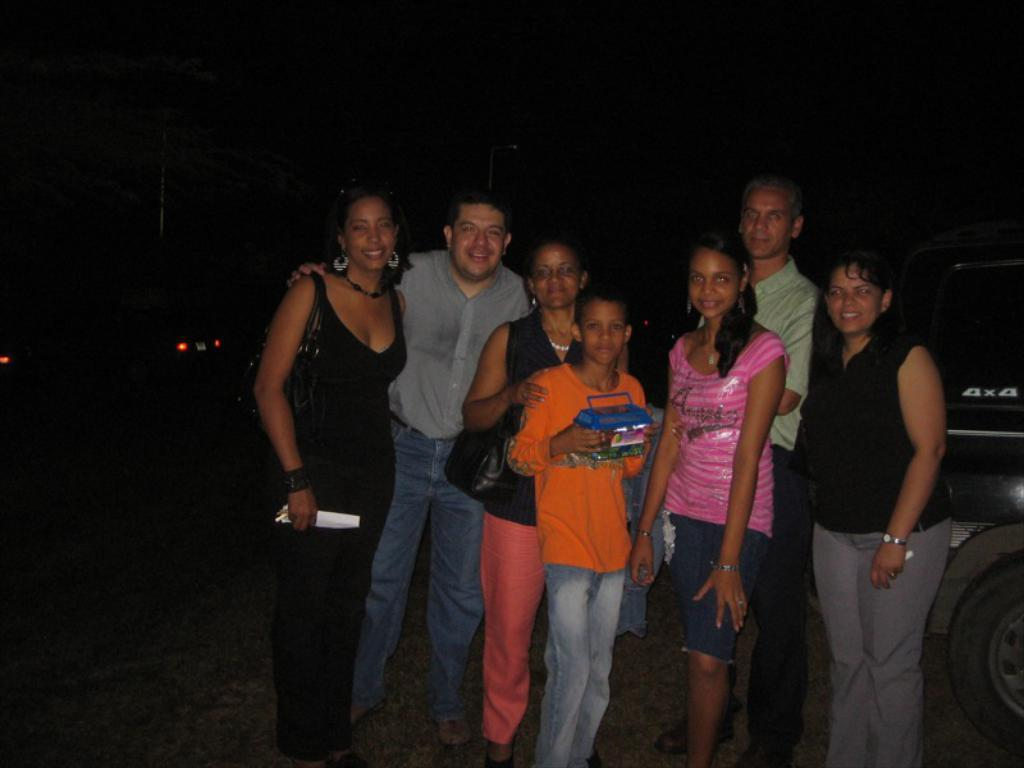What is happening in the foreground of the image? There is a group of people in the foreground of the image, and they are standing and posing for a photo. Can you describe the position of the people in the image? The people are standing in the image. What can be seen in the background of the image? There is a vehicle visible in the background of the image. What is the rate of lumber production in the image? There is no mention of lumber production or any related activities in the image, so it is not possible to determine the rate of lumber production. 